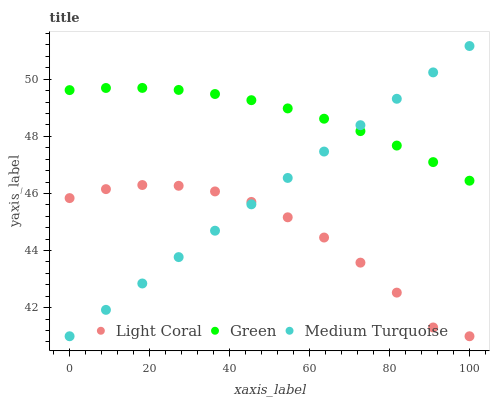Does Light Coral have the minimum area under the curve?
Answer yes or no. Yes. Does Green have the maximum area under the curve?
Answer yes or no. Yes. Does Medium Turquoise have the minimum area under the curve?
Answer yes or no. No. Does Medium Turquoise have the maximum area under the curve?
Answer yes or no. No. Is Medium Turquoise the smoothest?
Answer yes or no. Yes. Is Light Coral the roughest?
Answer yes or no. Yes. Is Green the smoothest?
Answer yes or no. No. Is Green the roughest?
Answer yes or no. No. Does Light Coral have the lowest value?
Answer yes or no. Yes. Does Green have the lowest value?
Answer yes or no. No. Does Medium Turquoise have the highest value?
Answer yes or no. Yes. Does Green have the highest value?
Answer yes or no. No. Is Light Coral less than Green?
Answer yes or no. Yes. Is Green greater than Light Coral?
Answer yes or no. Yes. Does Medium Turquoise intersect Green?
Answer yes or no. Yes. Is Medium Turquoise less than Green?
Answer yes or no. No. Is Medium Turquoise greater than Green?
Answer yes or no. No. Does Light Coral intersect Green?
Answer yes or no. No. 